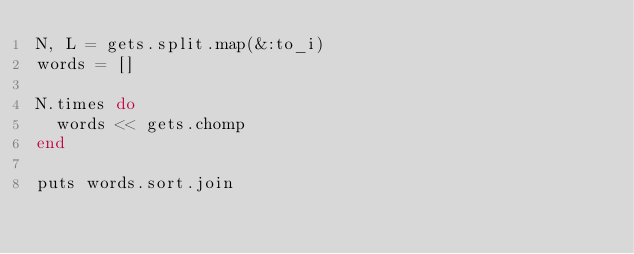<code> <loc_0><loc_0><loc_500><loc_500><_Ruby_>N, L = gets.split.map(&:to_i)
words = []

N.times do
  words << gets.chomp
end

puts words.sort.join</code> 